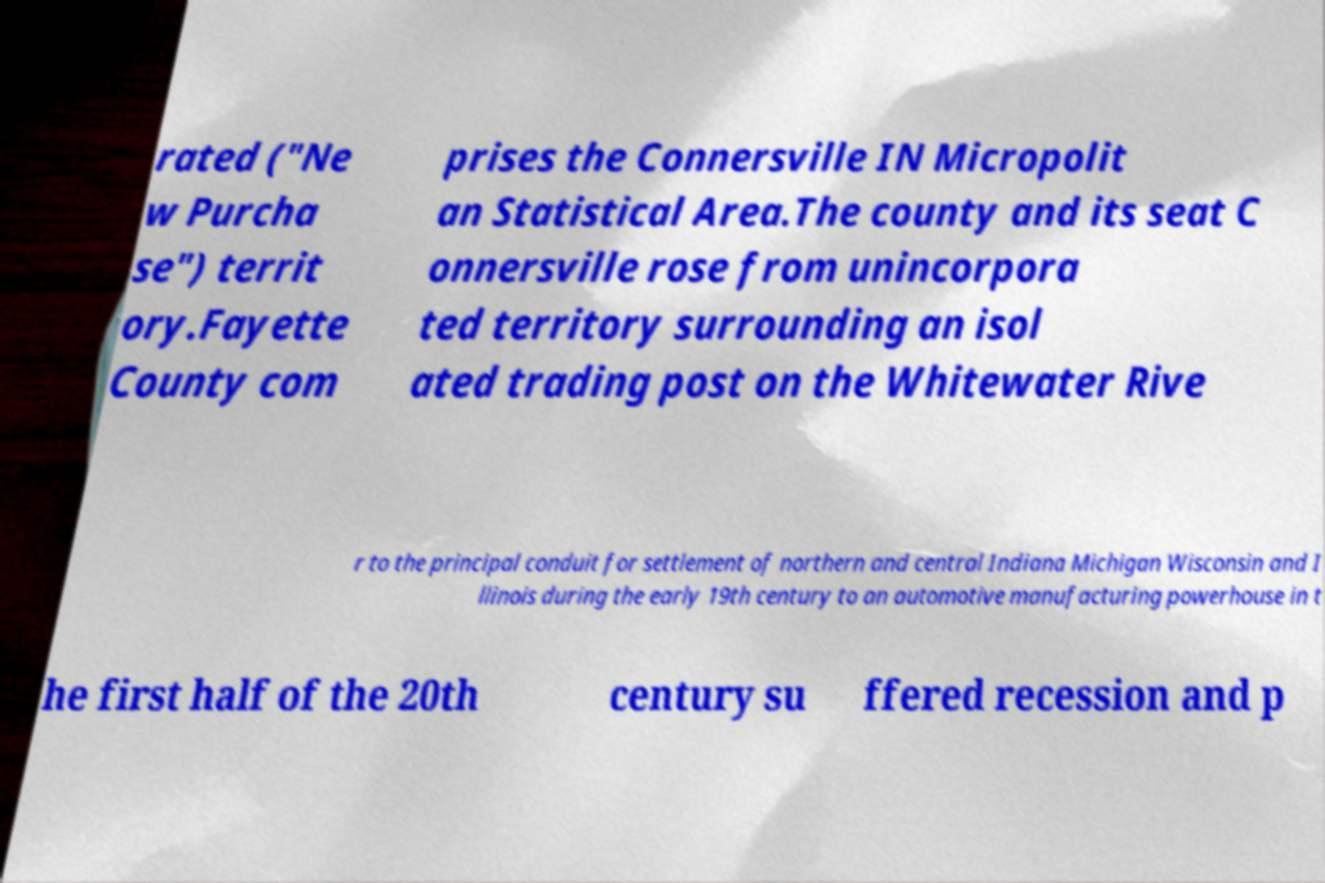I need the written content from this picture converted into text. Can you do that? rated ("Ne w Purcha se") territ ory.Fayette County com prises the Connersville IN Micropolit an Statistical Area.The county and its seat C onnersville rose from unincorpora ted territory surrounding an isol ated trading post on the Whitewater Rive r to the principal conduit for settlement of northern and central Indiana Michigan Wisconsin and I llinois during the early 19th century to an automotive manufacturing powerhouse in t he first half of the 20th century su ffered recession and p 